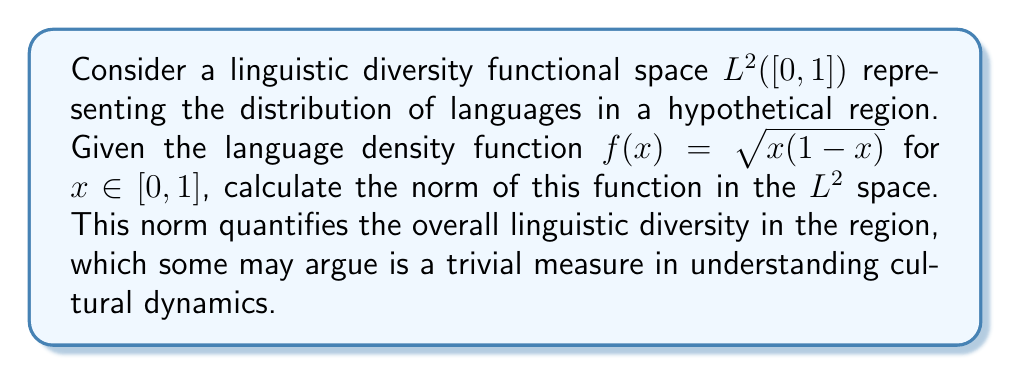Could you help me with this problem? To calculate the norm of the function $f(x) = \sqrt{x(1-x)}$ in the $L^2([0,1])$ space, we need to follow these steps:

1) The norm in $L^2([0,1])$ is defined as:

   $$\|f\|_2 = \sqrt{\int_0^1 |f(x)|^2 dx}$$

2) Substitute our function $f(x) = \sqrt{x(1-x)}$ into the integral:

   $$\|f\|_2 = \sqrt{\int_0^1 (\sqrt{x(1-x)})^2 dx}$$

3) Simplify the integrand:

   $$\|f\|_2 = \sqrt{\int_0^1 x(1-x) dx}$$

4) Expand the integrand:

   $$\|f\|_2 = \sqrt{\int_0^1 (x - x^2) dx}$$

5) Integrate:

   $$\|f\|_2 = \sqrt{\left[\frac{x^2}{2} - \frac{x^3}{3}\right]_0^1}$$

6) Evaluate the integral:

   $$\|f\|_2 = \sqrt{\left(\frac{1}{2} - \frac{1}{3}\right) - (0 - 0)}$$

7) Simplify:

   $$\|f\|_2 = \sqrt{\frac{1}{6}} = \frac{1}{\sqrt{6}}$$
Answer: $\frac{1}{\sqrt{6}}$ 